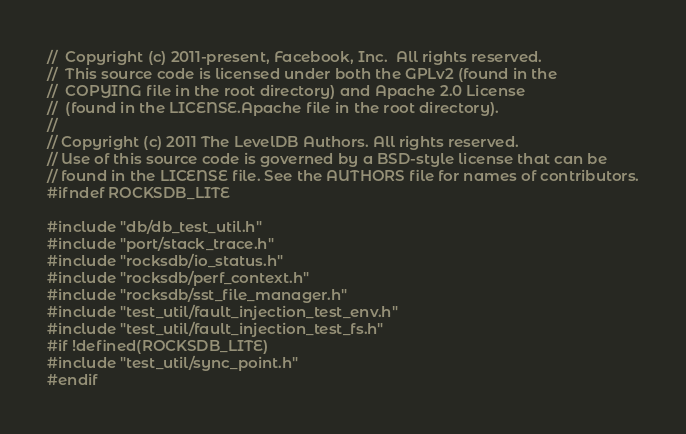Convert code to text. <code><loc_0><loc_0><loc_500><loc_500><_C++_>//  Copyright (c) 2011-present, Facebook, Inc.  All rights reserved.
//  This source code is licensed under both the GPLv2 (found in the
//  COPYING file in the root directory) and Apache 2.0 License
//  (found in the LICENSE.Apache file in the root directory).
//
// Copyright (c) 2011 The LevelDB Authors. All rights reserved.
// Use of this source code is governed by a BSD-style license that can be
// found in the LICENSE file. See the AUTHORS file for names of contributors.
#ifndef ROCKSDB_LITE

#include "db/db_test_util.h"
#include "port/stack_trace.h"
#include "rocksdb/io_status.h"
#include "rocksdb/perf_context.h"
#include "rocksdb/sst_file_manager.h"
#include "test_util/fault_injection_test_env.h"
#include "test_util/fault_injection_test_fs.h"
#if !defined(ROCKSDB_LITE)
#include "test_util/sync_point.h"
#endif
</code> 